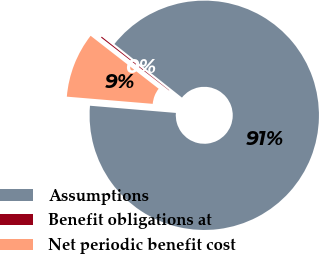<chart> <loc_0><loc_0><loc_500><loc_500><pie_chart><fcel>Assumptions<fcel>Benefit obligations at<fcel>Net periodic benefit cost<nl><fcel>90.65%<fcel>0.15%<fcel>9.2%<nl></chart> 